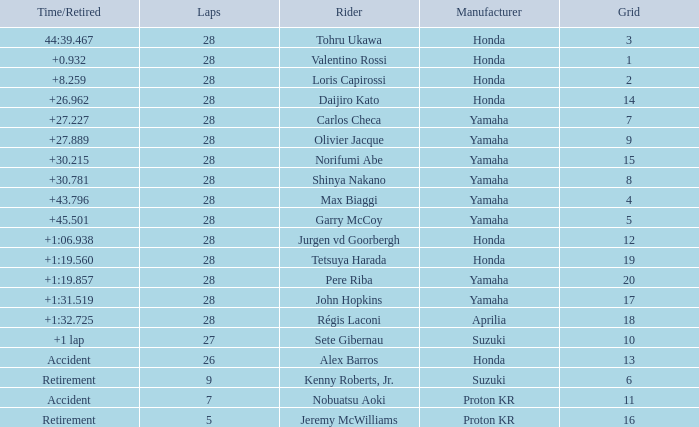How many laps were in grid 4? 28.0. 